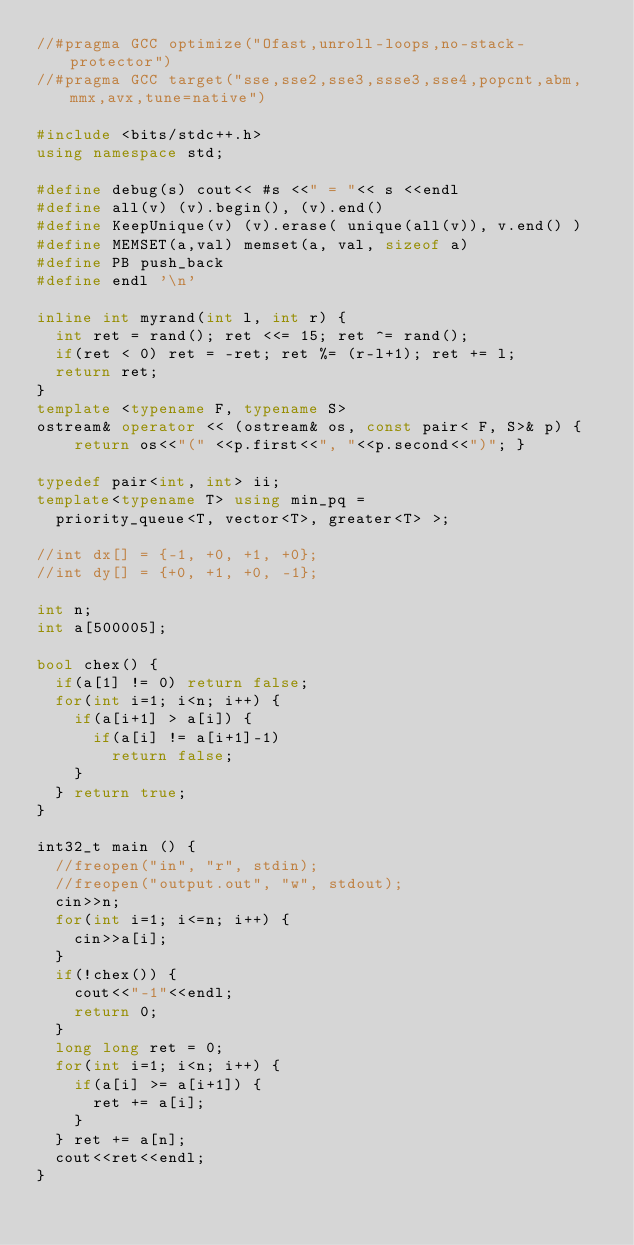<code> <loc_0><loc_0><loc_500><loc_500><_C++_>//#pragma GCC optimize("Ofast,unroll-loops,no-stack-protector")
//#pragma GCC target("sse,sse2,sse3,ssse3,sse4,popcnt,abm,mmx,avx,tune=native")

#include <bits/stdc++.h>
using namespace std;

#define debug(s) cout<< #s <<" = "<< s <<endl
#define all(v) (v).begin(), (v).end()
#define KeepUnique(v) (v).erase( unique(all(v)), v.end() )
#define MEMSET(a,val) memset(a, val, sizeof a)
#define PB push_back
#define endl '\n'

inline int myrand(int l, int r) {
	int ret = rand(); ret <<= 15; ret ^= rand();
	if(ret < 0) ret = -ret; ret %= (r-l+1); ret += l;
	return ret;
}
template <typename F, typename S>
ostream& operator << (ostream& os, const pair< F, S>& p) {
    return os<<"(" <<p.first<<", "<<p.second<<")"; }

typedef pair<int, int> ii;
template<typename T> using min_pq =
	priority_queue<T, vector<T>, greater<T> >;

//int dx[] = {-1, +0, +1, +0};
//int dy[] = {+0, +1, +0, -1};

int n;
int a[500005];

bool chex() {
	if(a[1] != 0) return false;
	for(int i=1; i<n; i++) {
		if(a[i+1] > a[i]) {
			if(a[i] != a[i+1]-1)
				return false;
		}
	} return true;
}

int32_t main () {
	//freopen("in", "r", stdin);
	//freopen("output.out", "w", stdout);
	cin>>n;
	for(int i=1; i<=n; i++) {
		cin>>a[i];
	}
	if(!chex()) {
		cout<<"-1"<<endl;
		return 0;
	}
	long long ret = 0;
	for(int i=1; i<n; i++) {
		if(a[i] >= a[i+1]) {
			ret += a[i];
		}
	} ret += a[n];
	cout<<ret<<endl;
}</code> 